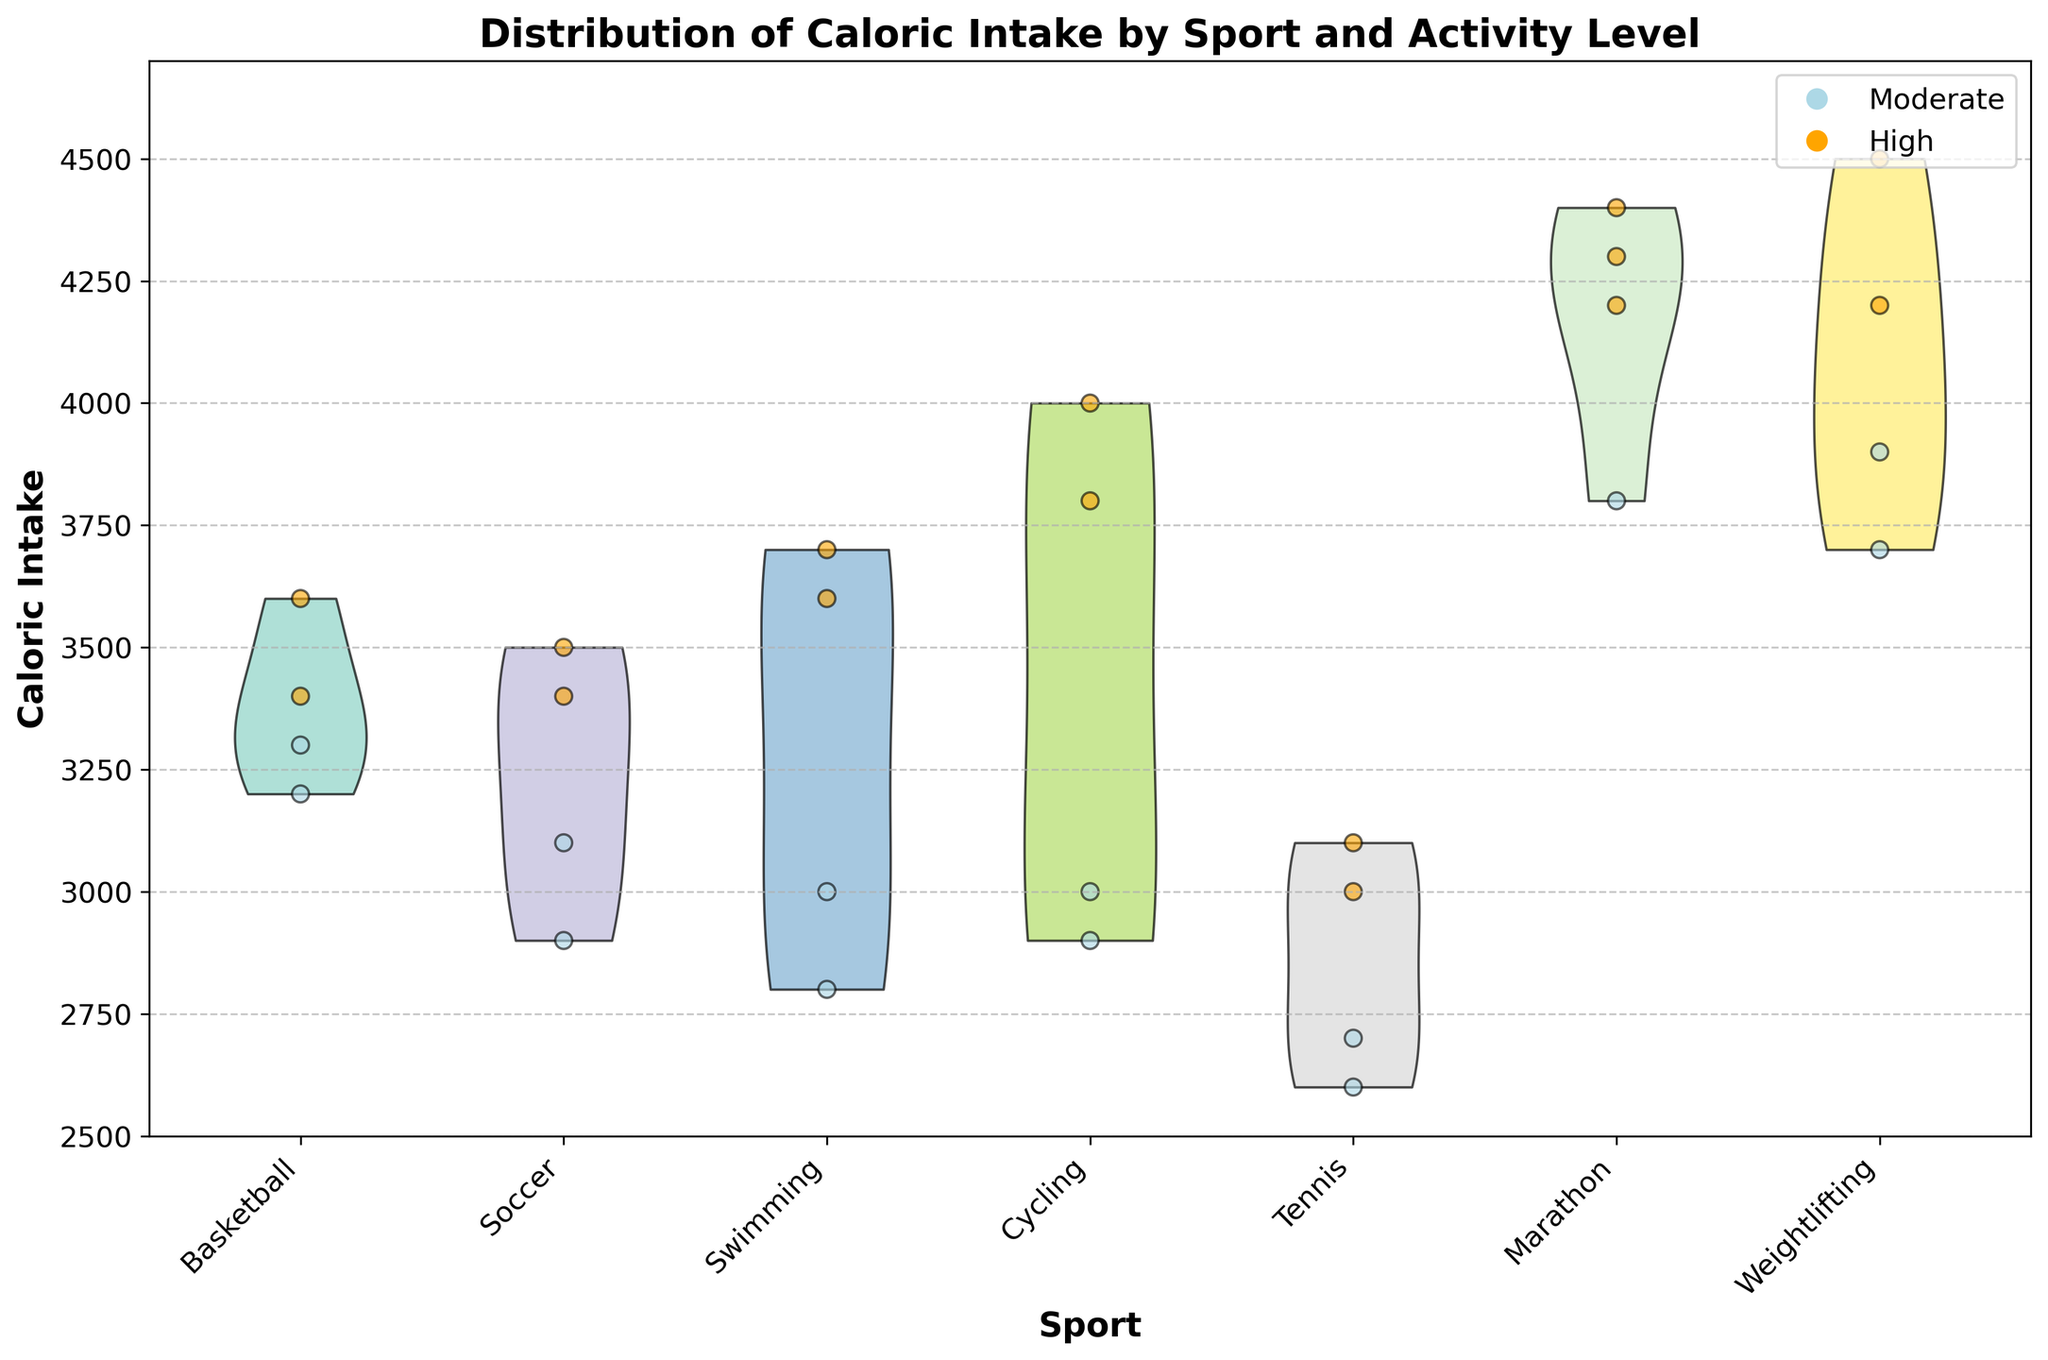What's the title of the figure? The title is usually found at the top of the figure and briefly describes the content or purpose of the visualization.
Answer: Distribution of Caloric Intake by Sport and Activity Level What does the x-axis represent? The x-axis typically has labels or ticks that indicate the categories or groups being compared in the plot. In this case, it represents the different sports.
Answer: Sport Which sport has the highest caloric intake for high activity levels? By focusing on the data points colored in orange (high activity level) and checking their highest values, we observe the sport with the highest caloric intake.
Answer: Marathon How many sports are represented in the figure? The number of different sports can be counted based on the separate labels on the x-axis.
Answer: 6 What is the color used to represent moderate activity level? The legend on the plot often indicates which colors correspond to different variables or activity levels.
Answer: Light blue For which sport does the caloric intake have the widest distribution? The violin plot's shape indicates the distribution's spread. The widest plot indicates the largest range of caloric intake values for a sport.
Answer: Weightlifting Compare the median caloric intake for Soccer and Tennis during high activity levels. Which has a higher median? Focusing on the central tendency of the orange datapoints (high activity) for both sports on the x-axis will show which has a higher median.
Answer: Soccer What range of caloric intake is observed in Swimming at moderate activity level? Observing the light blue data points within the violin plot for Swimming will show the range from the lowest to the highest point in that category.
Answer: 2800-3000 What sport appears to have the most consistent caloric intake among high activity level athletes? The consistency can be judged by the narrowness or thickness of the orange portions of the violin plots. The sport with the narrowest band has the most consistent intake.
Answer: Tennis Which sport shows the highest difference in caloric intake between moderate and high activity levels? By visually comparing the difference between the light blue (moderate) and orange (high) data points across each sport, we can determine which has the greatest gap.
Answer: Marathon 